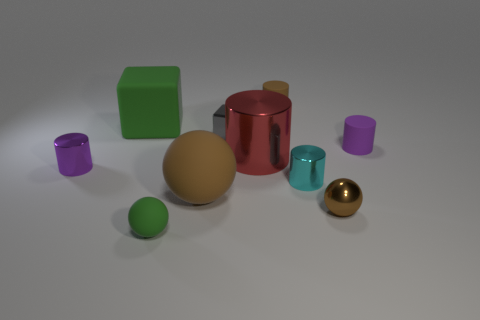There is a tiny rubber thing that is left of the large cylinder; is its color the same as the big rubber cube?
Your answer should be very brief. Yes. There is a purple object to the left of the red thing; are there any small brown objects on the right side of it?
Provide a succinct answer. Yes. Is the number of large metal objects behind the small green object less than the number of matte objects on the left side of the cyan object?
Make the answer very short. Yes. There is a green matte thing behind the tiny metallic cylinder that is left of the small rubber thing that is in front of the big metallic object; what size is it?
Your response must be concise. Large. Do the green object that is in front of the gray thing and the red metal cylinder have the same size?
Your response must be concise. No. How many other objects are there of the same material as the large cylinder?
Your answer should be compact. 4. Is the number of small cyan shiny things greater than the number of tiny metallic things?
Make the answer very short. No. There is a cylinder in front of the tiny purple cylinder left of the tiny ball that is behind the tiny green matte thing; what is it made of?
Ensure brevity in your answer.  Metal. Does the large rubber block have the same color as the tiny rubber sphere?
Make the answer very short. Yes. Are there any objects of the same color as the small shiny ball?
Offer a very short reply. Yes. 